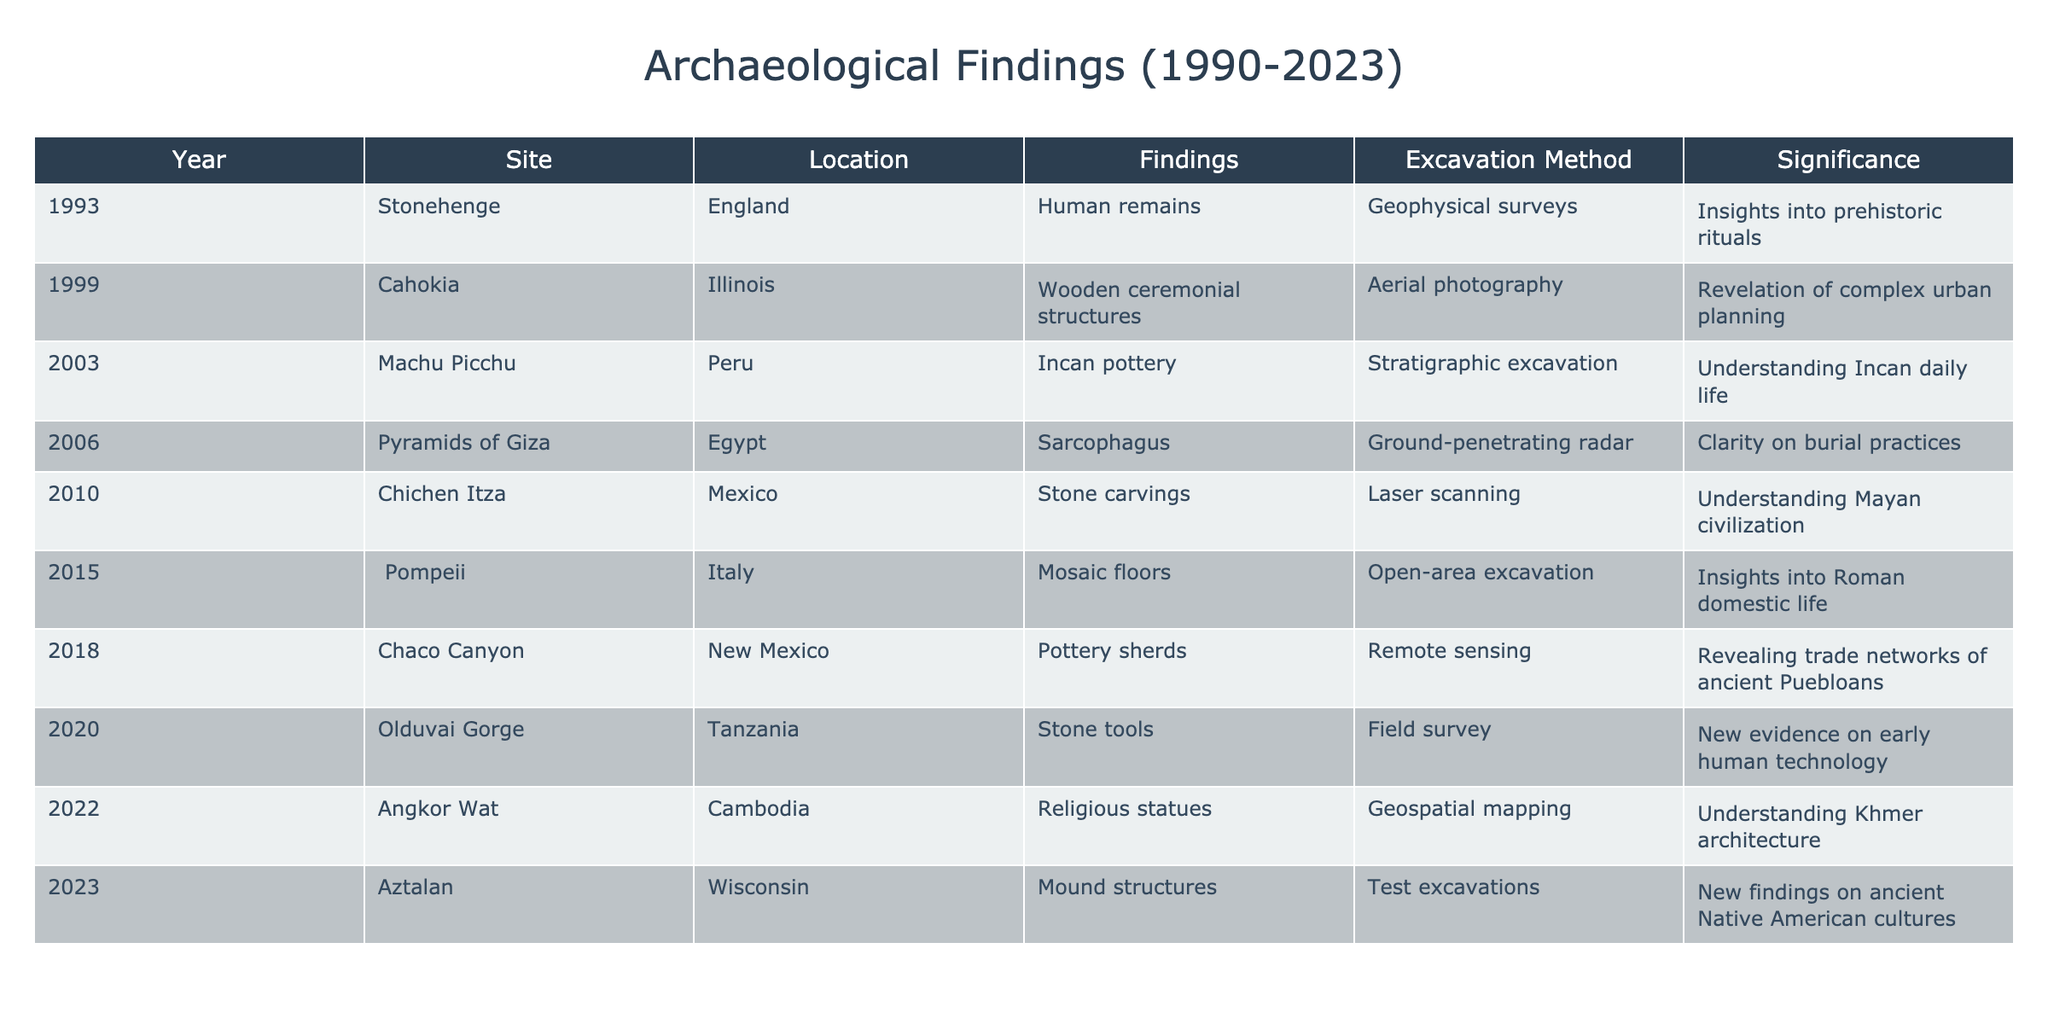What year was the excavation at Machu Picchu conducted? The table shows that the excavation at Machu Picchu took place in the year 2003.
Answer: 2003 Which site had findings related to human remains? According to the table, the site that had findings related to human remains is Stonehenge, which was excavated in 1993.
Answer: Stonehenge In how many years from 1990 to 2023 were finds related to pottery made? The table indicates that findings related to pottery occurred at Machu Picchu in 2003, at Chaco Canyon in 2018, and later at Aztalan in 2023. That makes a total of three years.
Answer: 3 Did the excavation at Angkor Wat involve remote sensing as the excavation method? The table specifies that Angkor Wat was excavated using geospatial mapping, not remote sensing. Therefore, the answer is no.
Answer: No What significance is associated with the findings at Olduvai Gorge? The table states that the significance of the findings at Olduvai Gorge in 2020 is new evidence on early human technology.
Answer: New evidence on early human technology Which site had the earliest excavation, and what was discovered there? The earliest excavation listed in the table is Stonehenge, where human remains were discovered in 1993.
Answer: Stonehenge, human remains What is the total number of unique excavation methods used in these findings? By examining the table, we can list the unique excavation methods: Geophysical surveys, aerial photography, stratigraphic excavation, ground-penetrating radar, laser scanning, open-area excavation, remote sensing, field survey, and geospatial mapping. This results in a total of nine unique methods.
Answer: 9 Which site listed in 2022 had findings related to religious artifacts? The table shows that the site Angkor Wat in 2022 had findings related to religious statues, which fall under religious artifacts.
Answer: Angkor Wat How many findings were associated with ancient Native American cultures? The table indicates that there is one finding associated with ancient Native American cultures, which is noted in the Aztalan excavation in 2023.
Answer: 1 